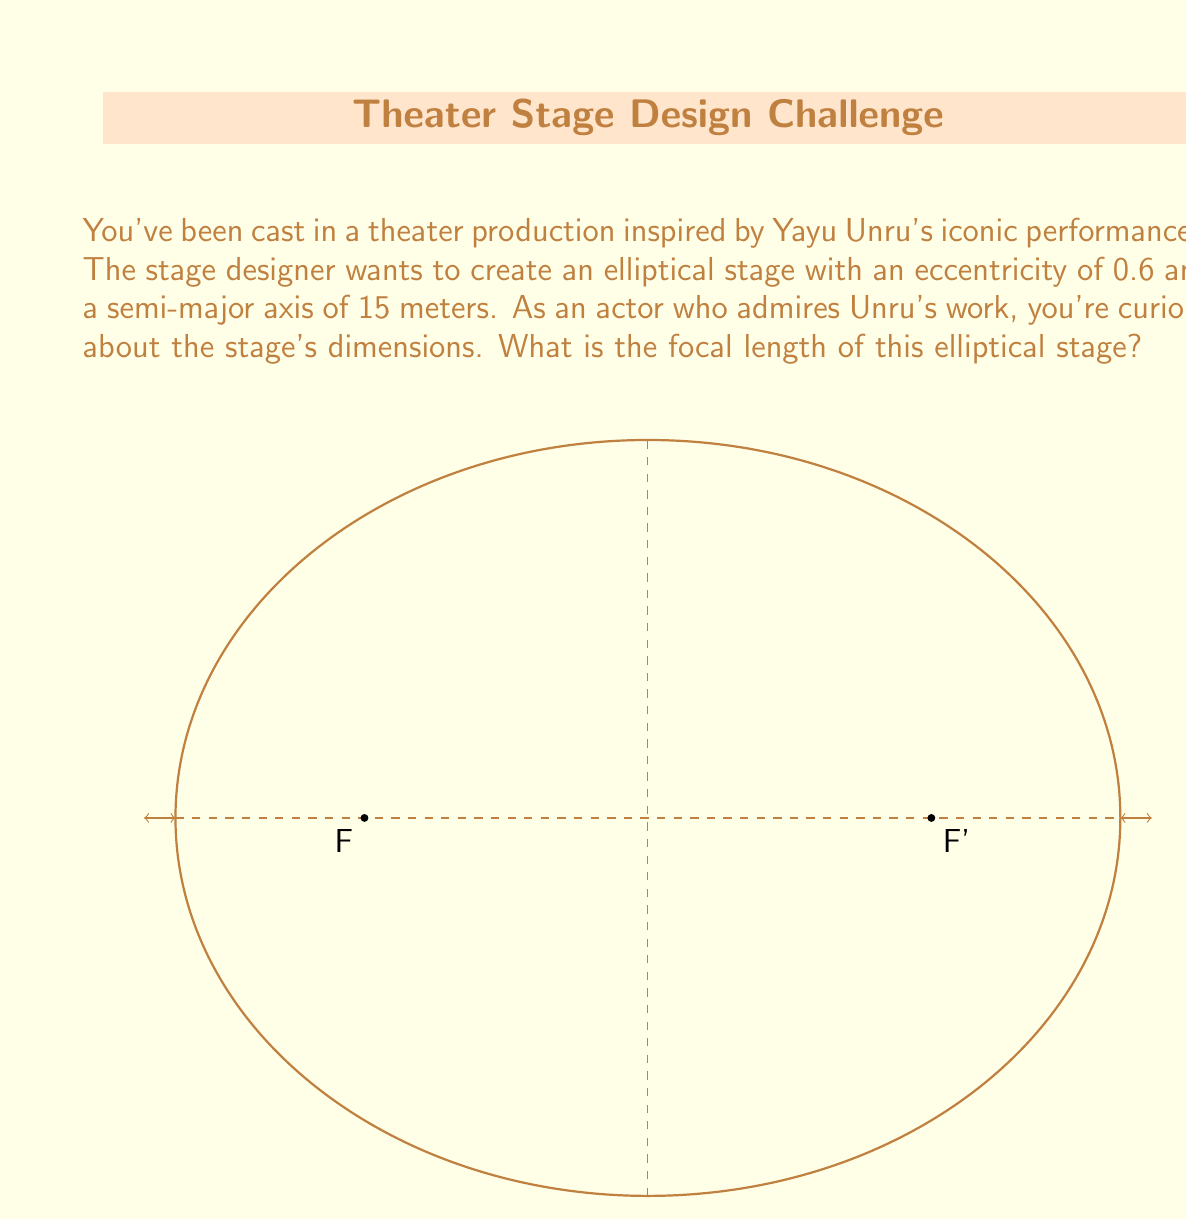Can you solve this math problem? Let's approach this step-by-step:

1) In an ellipse, the relationship between the semi-major axis (a), eccentricity (e), and focal length (c) is given by:

   $$c = ae$$

2) We are given:
   - Eccentricity, e = 0.6
   - Semi-major axis, a = 15 meters

3) Let's substitute these values into the equation:

   $$c = 15 \cdot 0.6$$

4) Now, let's calculate:

   $$c = 9$$

5) The focal length is the distance from the center to either focus. Since we calculated c, which is this exact distance, our answer is 9 meters.

Note: In the context of Yayu Unru's performances, this elliptical stage design could create interesting opportunities for dynamic movement and staging, allowing actors to utilize the unique shape for dramatic effect.
Answer: 9 meters 